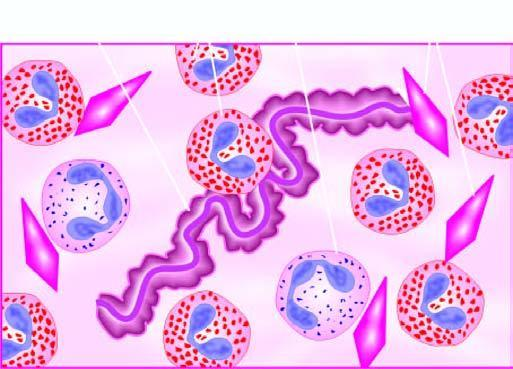does diagrammatic appearance of curschmann 's spiral and charcot-leyden crystals found in mucus plug in patients with bronchial asthma?
Answer the question using a single word or phrase. Yes 